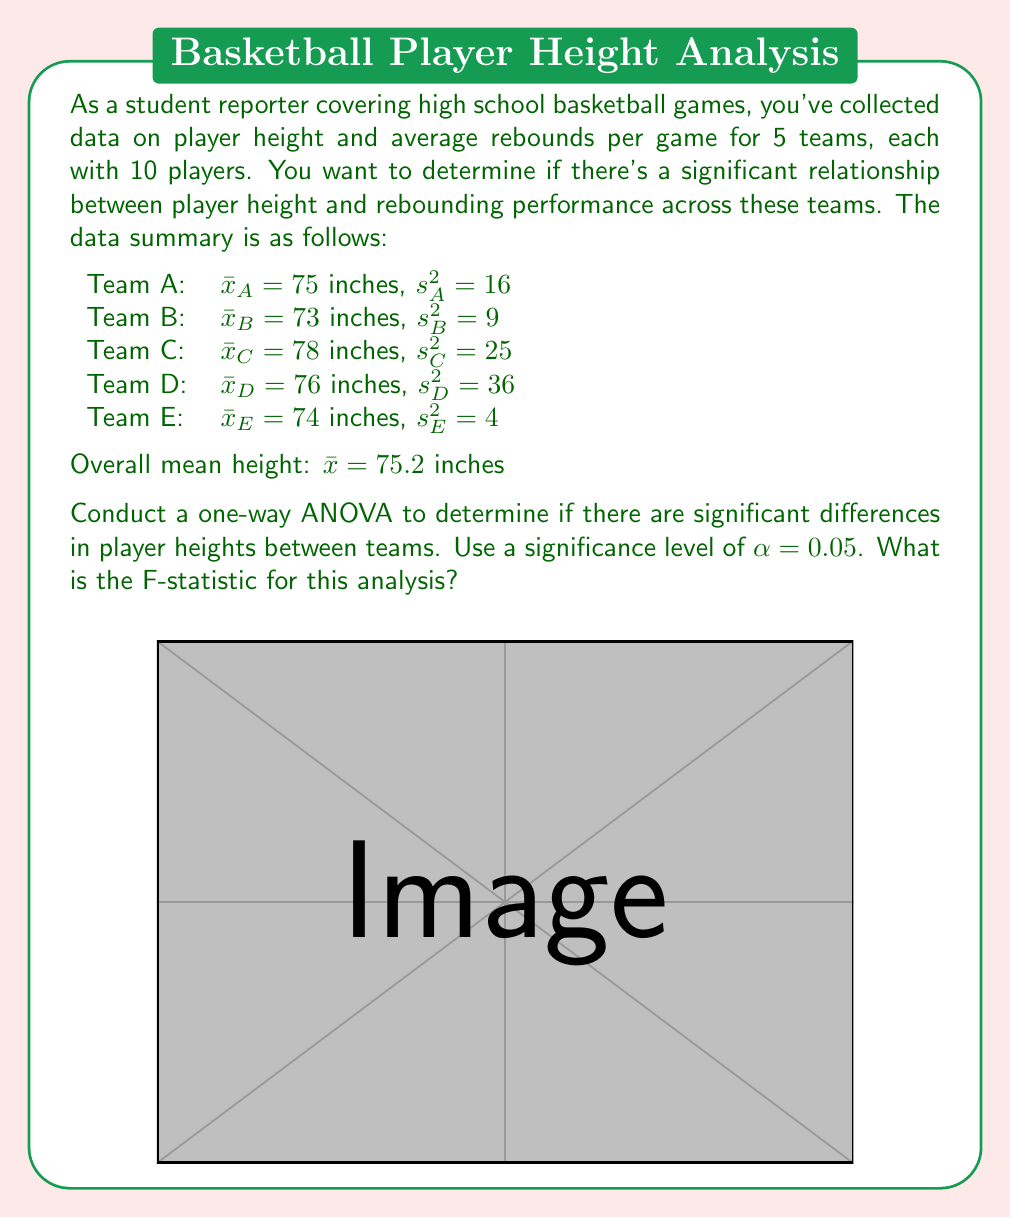Can you solve this math problem? To conduct a one-way ANOVA and calculate the F-statistic, we need to follow these steps:

1. Calculate the Sum of Squares Between (SSB):
   $$SSB = \sum_{i=1}^k n_i(\bar{x}_i - \bar{x})^2$$
   where $k$ is the number of groups (teams), $n_i$ is the number of players per team (10), $\bar{x}_i$ is the mean height of each team, and $\bar{x}$ is the overall mean height.

   $$SSB = 10[(75-75.2)^2 + (73-75.2)^2 + (78-75.2)^2 + (76-75.2)^2 + (74-75.2)^2]$$
   $$SSB = 10[0.04 + 4.84 + 7.84 + 0.64 + 1.44] = 148$$

2. Calculate the Sum of Squares Within (SSW):
   $$SSW = \sum_{i=1}^k (n_i - 1)s_i^2$$
   where $s_i^2$ is the variance of each team.

   $$SSW = 9(16 + 9 + 25 + 36 + 4) = 810$$

3. Calculate the degrees of freedom:
   Between groups: $df_B = k - 1 = 5 - 1 = 4$
   Within groups: $df_W = N - k = 50 - 5 = 45$
   where $N$ is the total number of players.

4. Calculate the Mean Square Between (MSB) and Mean Square Within (MSW):
   $$MSB = \frac{SSB}{df_B} = \frac{148}{4} = 37$$
   $$MSW = \frac{SSW}{df_W} = \frac{810}{45} = 18$$

5. Calculate the F-statistic:
   $$F = \frac{MSB}{MSW} = \frac{37}{18} = 2.0556$$

The F-statistic for this analysis is approximately 2.0556.
Answer: $F = 2.0556$ 